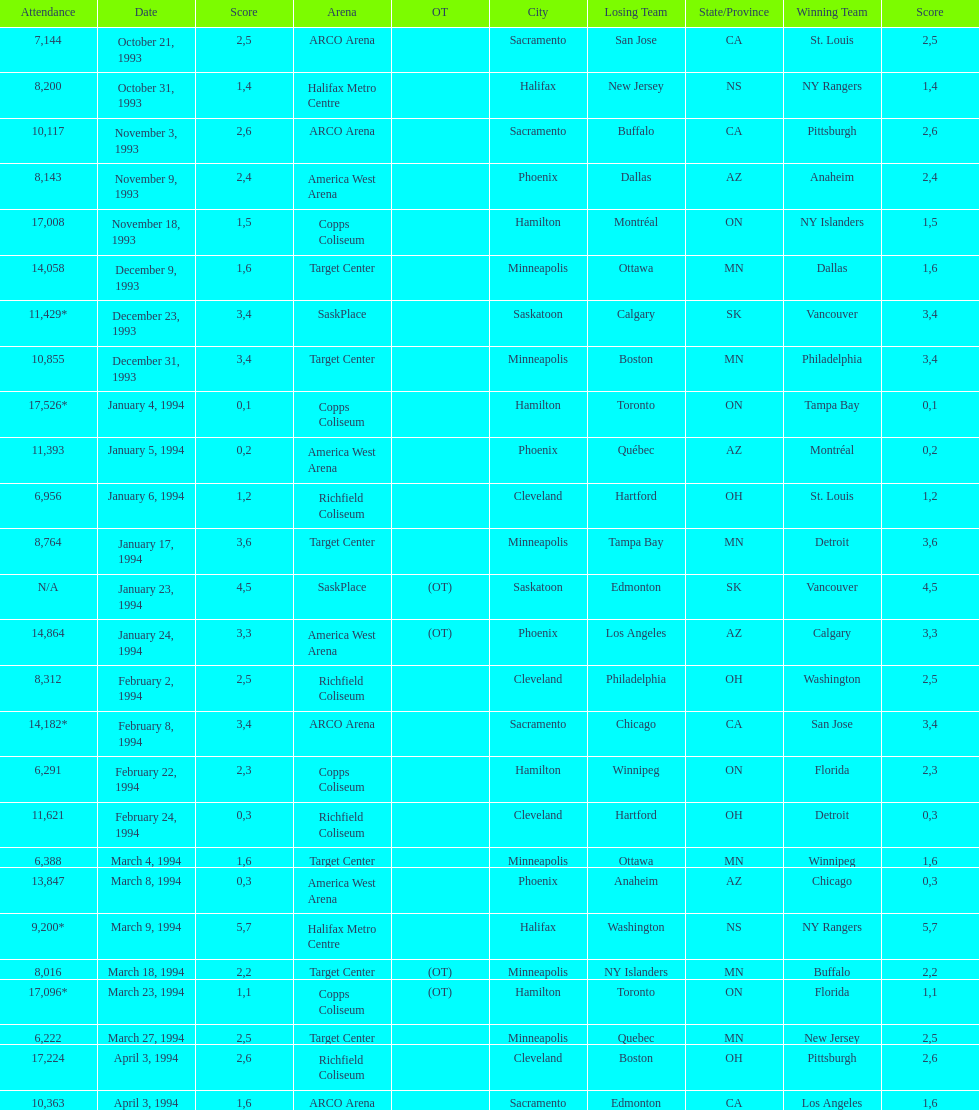The game on which date had the most attendance? January 4, 1994. 